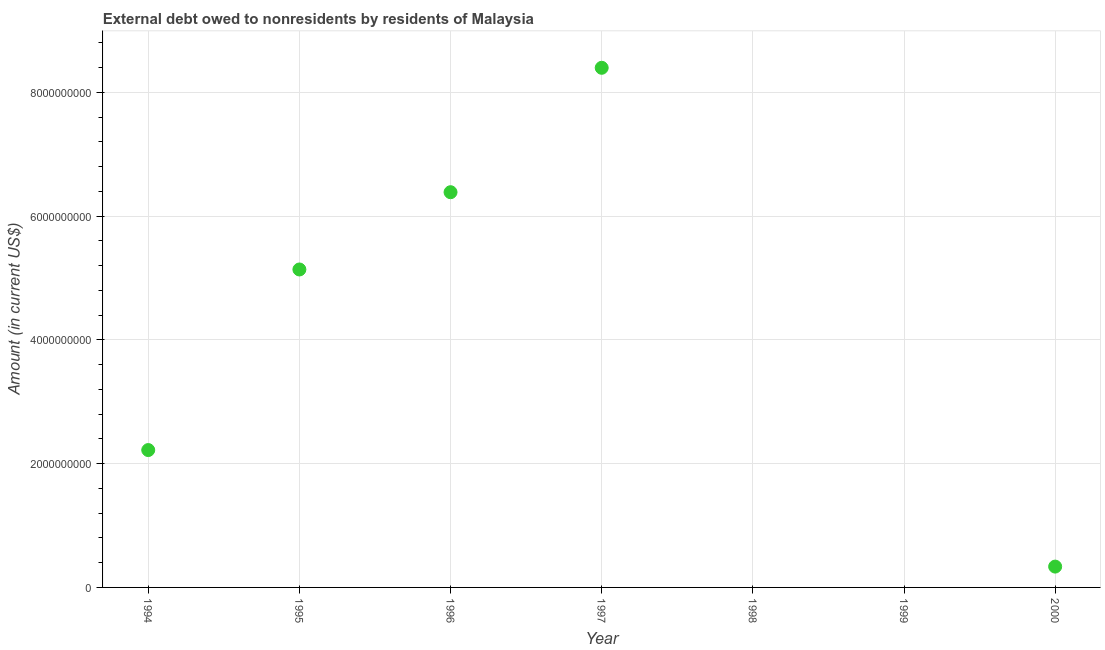What is the debt in 1997?
Ensure brevity in your answer.  8.40e+09. Across all years, what is the maximum debt?
Make the answer very short. 8.40e+09. What is the sum of the debt?
Offer a very short reply. 2.25e+1. What is the difference between the debt in 1996 and 1997?
Your response must be concise. -2.01e+09. What is the average debt per year?
Provide a succinct answer. 3.21e+09. What is the median debt?
Your answer should be very brief. 2.22e+09. What is the ratio of the debt in 1996 to that in 1997?
Give a very brief answer. 0.76. What is the difference between the highest and the second highest debt?
Offer a very short reply. 2.01e+09. What is the difference between the highest and the lowest debt?
Your response must be concise. 8.40e+09. In how many years, is the debt greater than the average debt taken over all years?
Make the answer very short. 3. Does the debt monotonically increase over the years?
Offer a terse response. No. How many years are there in the graph?
Ensure brevity in your answer.  7. What is the title of the graph?
Your answer should be compact. External debt owed to nonresidents by residents of Malaysia. What is the Amount (in current US$) in 1994?
Offer a very short reply. 2.22e+09. What is the Amount (in current US$) in 1995?
Provide a short and direct response. 5.14e+09. What is the Amount (in current US$) in 1996?
Keep it short and to the point. 6.39e+09. What is the Amount (in current US$) in 1997?
Your answer should be very brief. 8.40e+09. What is the Amount (in current US$) in 1998?
Your response must be concise. 0. What is the Amount (in current US$) in 2000?
Keep it short and to the point. 3.37e+08. What is the difference between the Amount (in current US$) in 1994 and 1995?
Provide a succinct answer. -2.92e+09. What is the difference between the Amount (in current US$) in 1994 and 1996?
Make the answer very short. -4.17e+09. What is the difference between the Amount (in current US$) in 1994 and 1997?
Make the answer very short. -6.18e+09. What is the difference between the Amount (in current US$) in 1994 and 2000?
Your response must be concise. 1.88e+09. What is the difference between the Amount (in current US$) in 1995 and 1996?
Your response must be concise. -1.25e+09. What is the difference between the Amount (in current US$) in 1995 and 1997?
Keep it short and to the point. -3.26e+09. What is the difference between the Amount (in current US$) in 1995 and 2000?
Make the answer very short. 4.80e+09. What is the difference between the Amount (in current US$) in 1996 and 1997?
Offer a terse response. -2.01e+09. What is the difference between the Amount (in current US$) in 1996 and 2000?
Your answer should be compact. 6.05e+09. What is the difference between the Amount (in current US$) in 1997 and 2000?
Keep it short and to the point. 8.06e+09. What is the ratio of the Amount (in current US$) in 1994 to that in 1995?
Offer a very short reply. 0.43. What is the ratio of the Amount (in current US$) in 1994 to that in 1996?
Offer a very short reply. 0.35. What is the ratio of the Amount (in current US$) in 1994 to that in 1997?
Give a very brief answer. 0.26. What is the ratio of the Amount (in current US$) in 1994 to that in 2000?
Your answer should be compact. 6.59. What is the ratio of the Amount (in current US$) in 1995 to that in 1996?
Ensure brevity in your answer.  0.81. What is the ratio of the Amount (in current US$) in 1995 to that in 1997?
Provide a succinct answer. 0.61. What is the ratio of the Amount (in current US$) in 1995 to that in 2000?
Offer a terse response. 15.26. What is the ratio of the Amount (in current US$) in 1996 to that in 1997?
Make the answer very short. 0.76. What is the ratio of the Amount (in current US$) in 1996 to that in 2000?
Make the answer very short. 18.97. What is the ratio of the Amount (in current US$) in 1997 to that in 2000?
Your answer should be very brief. 24.95. 